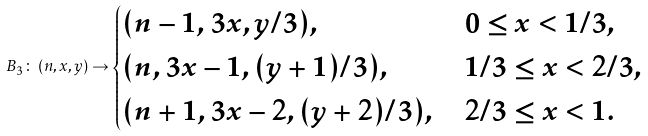Convert formula to latex. <formula><loc_0><loc_0><loc_500><loc_500>B _ { 3 } \colon \, ( n , x , y ) \rightarrow \begin{cases} ( n - 1 , 3 x , y / 3 ) , & 0 \leq x < 1 / 3 , \\ ( n , 3 x - 1 , ( y + 1 ) / 3 ) , & 1 / 3 \leq x < 2 / 3 , \\ ( n + 1 , 3 x - 2 , ( y + 2 ) / 3 ) , & 2 / 3 \leq x < 1 . \end{cases}</formula> 